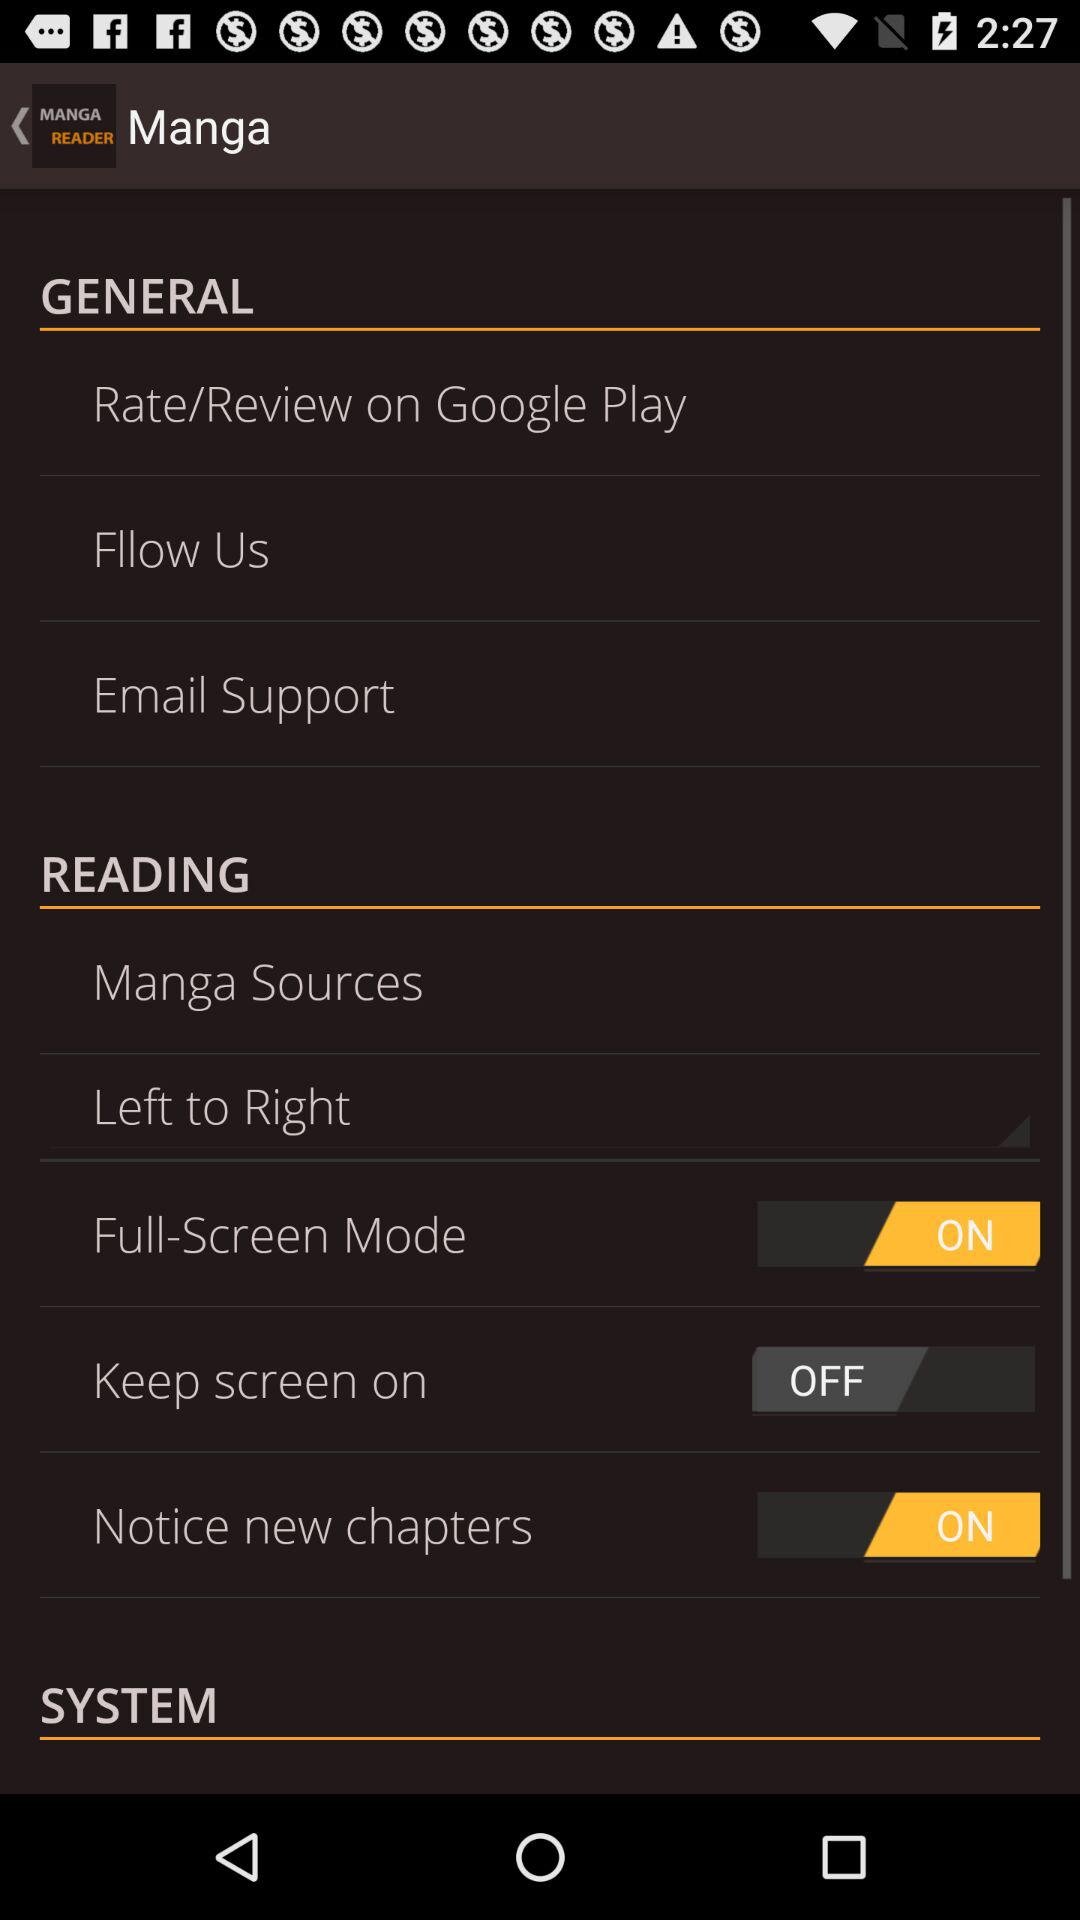What is the status of "Full-Screen Mode"? The status is "on". 